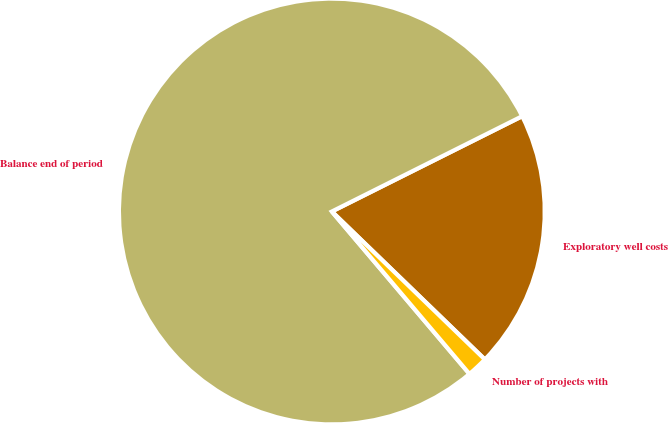<chart> <loc_0><loc_0><loc_500><loc_500><pie_chart><fcel>Exploratory well costs<fcel>Balance end of period<fcel>Number of projects with<nl><fcel>19.62%<fcel>78.8%<fcel>1.58%<nl></chart> 